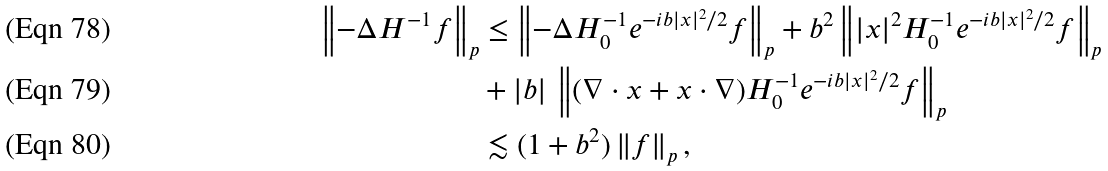Convert formula to latex. <formula><loc_0><loc_0><loc_500><loc_500>\left \| - \Delta H ^ { - 1 } f \right \| _ { p } & \leq \left \| - \Delta H _ { 0 } ^ { - 1 } e ^ { - i b | x | ^ { 2 } / 2 } f \right \| _ { p } + b ^ { 2 } \left \| | x | ^ { 2 } H _ { 0 } ^ { - 1 } e ^ { - i b | x | ^ { 2 } / 2 } f \right \| _ { p } \\ & + | b | \, \left \| ( \nabla \cdot x + x \cdot \nabla ) H _ { 0 } ^ { - 1 } e ^ { - i b | x | ^ { 2 } / 2 } f \right \| _ { p } \\ & \lesssim ( 1 + b ^ { 2 } ) \left \| f \right \| _ { p } ,</formula> 